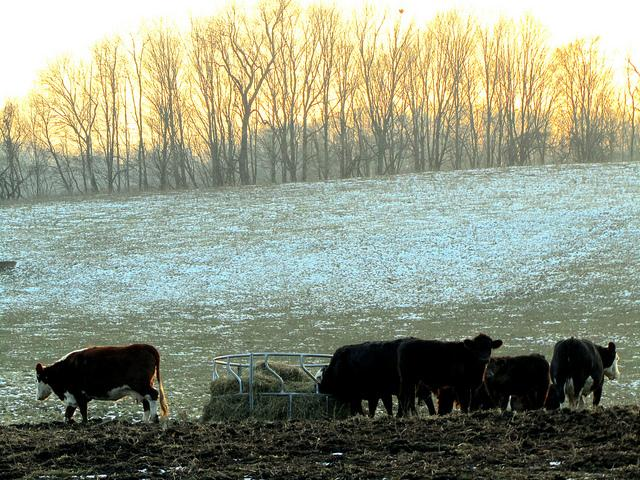What weather event happened recently? Please explain your reasoning. snow. White flakes can be seen on the ground. 